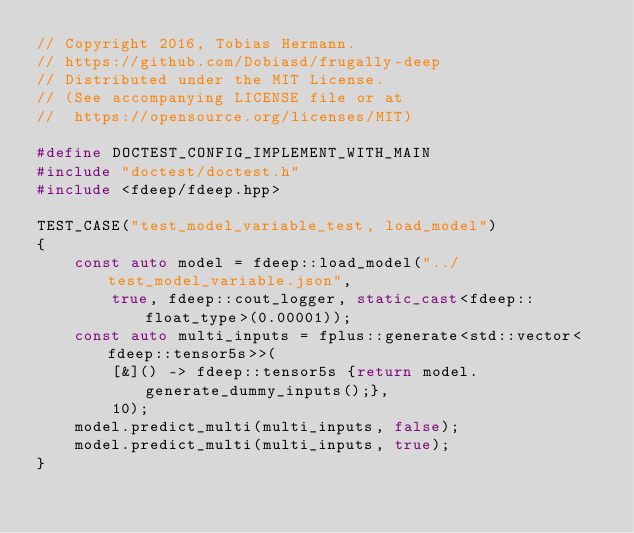<code> <loc_0><loc_0><loc_500><loc_500><_C++_>// Copyright 2016, Tobias Hermann.
// https://github.com/Dobiasd/frugally-deep
// Distributed under the MIT License.
// (See accompanying LICENSE file or at
//  https://opensource.org/licenses/MIT)

#define DOCTEST_CONFIG_IMPLEMENT_WITH_MAIN
#include "doctest/doctest.h"
#include <fdeep/fdeep.hpp>

TEST_CASE("test_model_variable_test, load_model")
{
    const auto model = fdeep::load_model("../test_model_variable.json",
        true, fdeep::cout_logger, static_cast<fdeep::float_type>(0.00001));
    const auto multi_inputs = fplus::generate<std::vector<fdeep::tensor5s>>(
        [&]() -> fdeep::tensor5s {return model.generate_dummy_inputs();},
        10);
    model.predict_multi(multi_inputs, false);
    model.predict_multi(multi_inputs, true);
}
</code> 